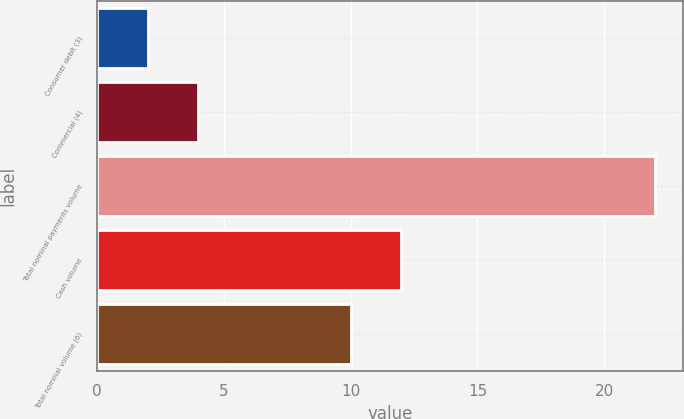Convert chart to OTSL. <chart><loc_0><loc_0><loc_500><loc_500><bar_chart><fcel>Consumer debit (3)<fcel>Commercial (4)<fcel>Total nominal payments volume<fcel>Cash volume<fcel>Total nominal volume (6)<nl><fcel>2<fcel>4<fcel>22<fcel>12<fcel>10<nl></chart> 